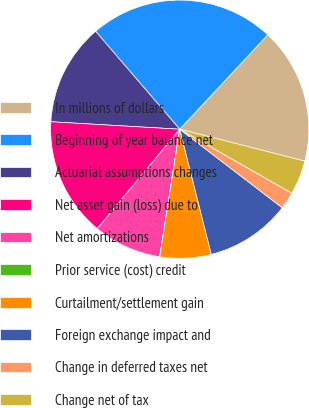Convert chart. <chart><loc_0><loc_0><loc_500><loc_500><pie_chart><fcel>In millions of dollars<fcel>Beginning of year balance net<fcel>Actuarial assumptions changes<fcel>Net asset gain (loss) due to<fcel>Net amortizations<fcel>Prior service (cost) credit<fcel>Curtailment/settlement gain<fcel>Foreign exchange impact and<fcel>Change in deferred taxes net<fcel>Change net of tax<nl><fcel>17.03%<fcel>23.24%<fcel>12.78%<fcel>14.91%<fcel>8.53%<fcel>0.02%<fcel>6.4%<fcel>10.66%<fcel>2.15%<fcel>4.28%<nl></chart> 